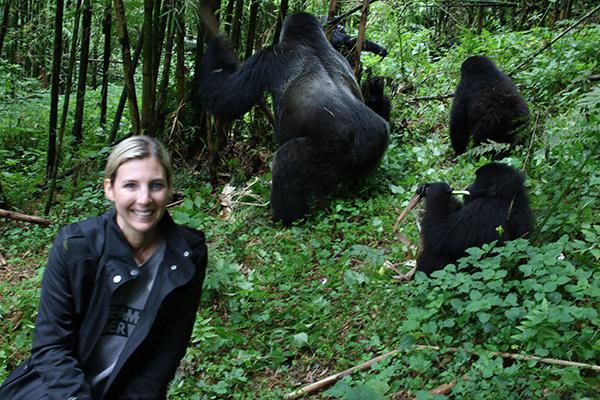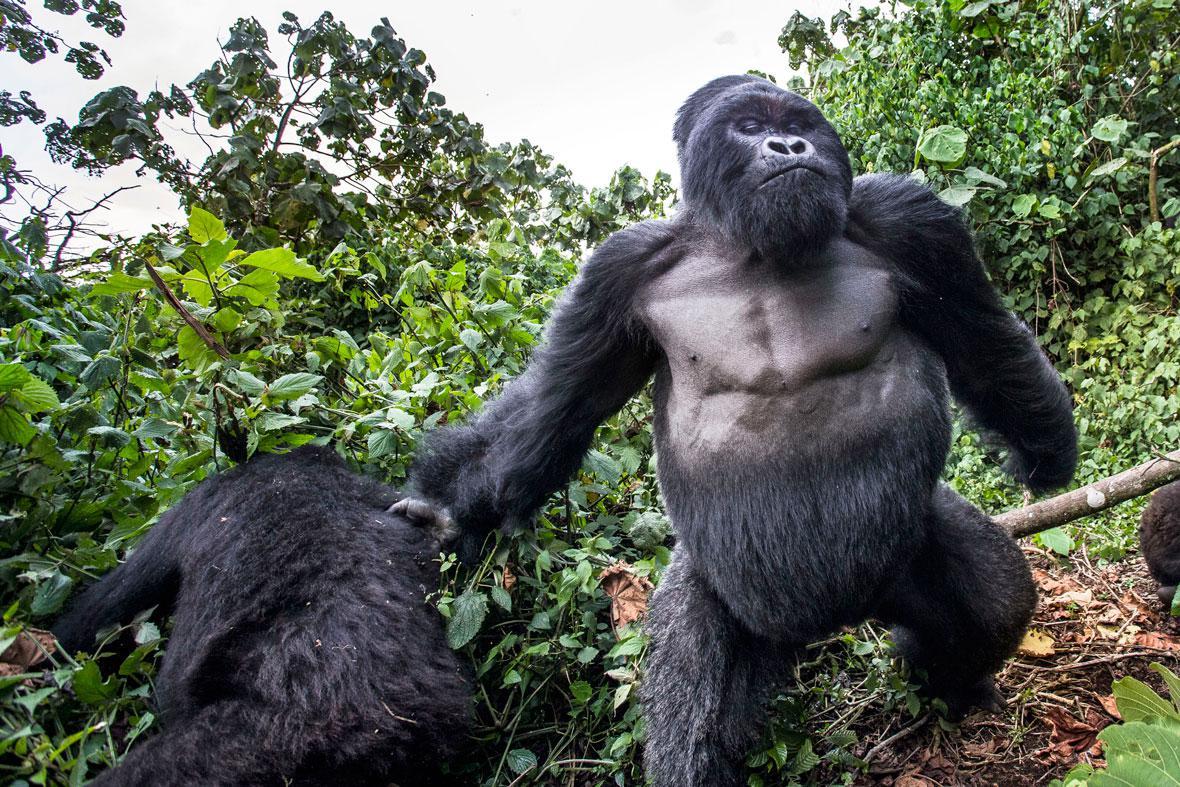The first image is the image on the left, the second image is the image on the right. Evaluate the accuracy of this statement regarding the images: "The right image includes an adult gorilla on all fours in the foreground, and the left image includes a large gorilla, multiple people, and someone upside down and off their feet.". Is it true? Answer yes or no. No. 